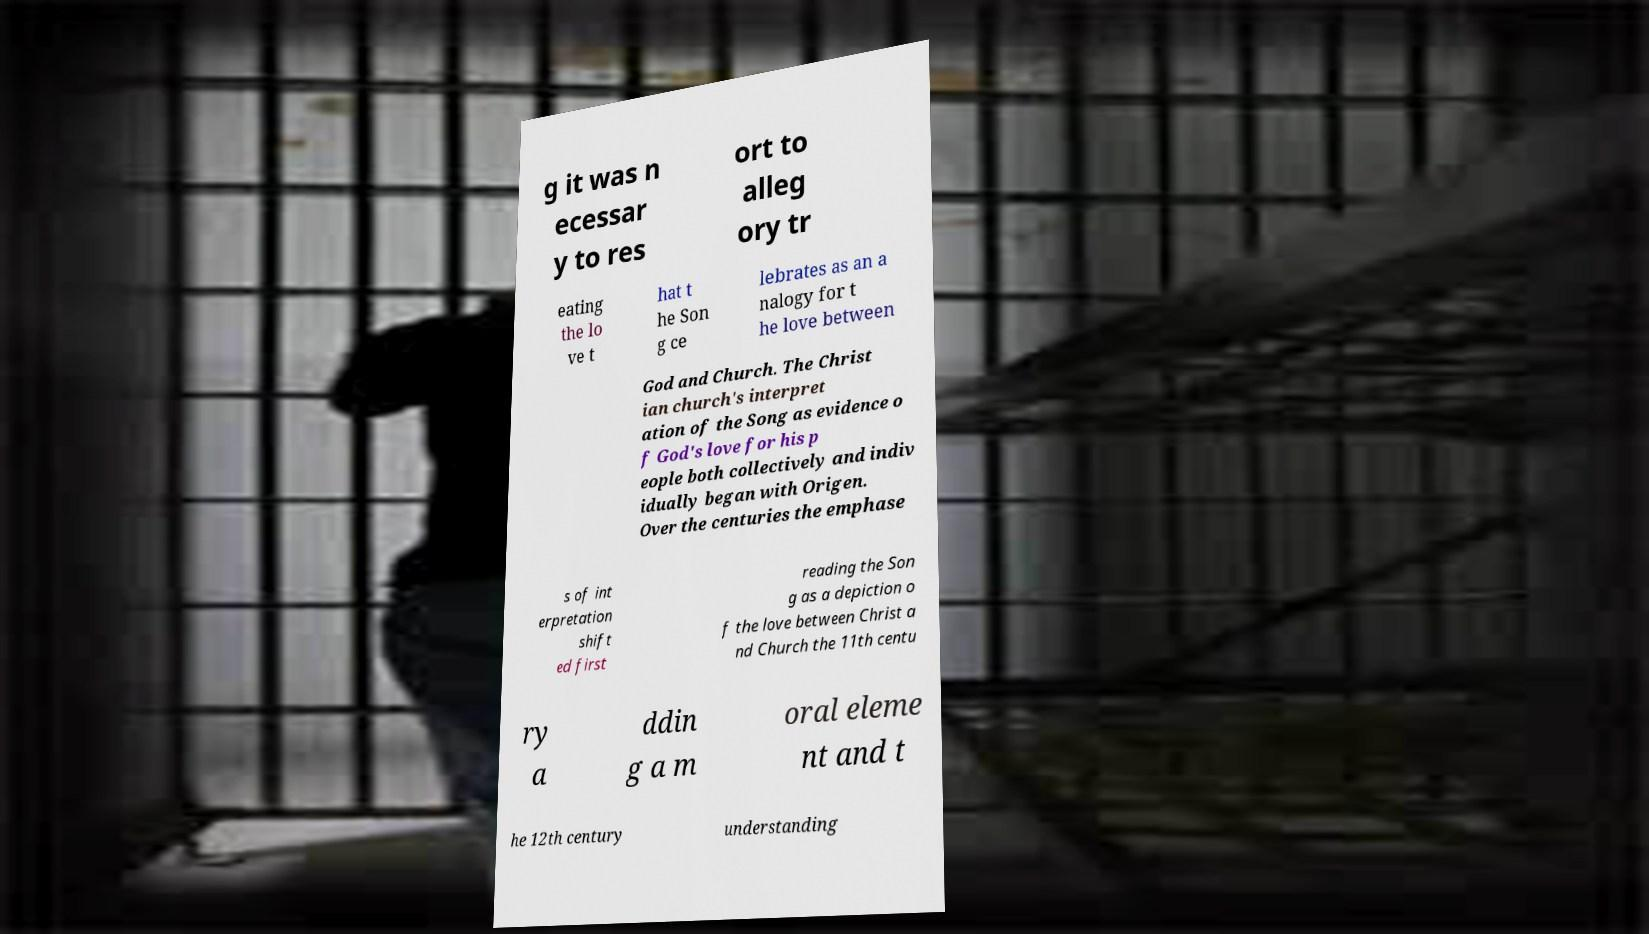Can you read and provide the text displayed in the image?This photo seems to have some interesting text. Can you extract and type it out for me? g it was n ecessar y to res ort to alleg ory tr eating the lo ve t hat t he Son g ce lebrates as an a nalogy for t he love between God and Church. The Christ ian church's interpret ation of the Song as evidence o f God's love for his p eople both collectively and indiv idually began with Origen. Over the centuries the emphase s of int erpretation shift ed first reading the Son g as a depiction o f the love between Christ a nd Church the 11th centu ry a ddin g a m oral eleme nt and t he 12th century understanding 